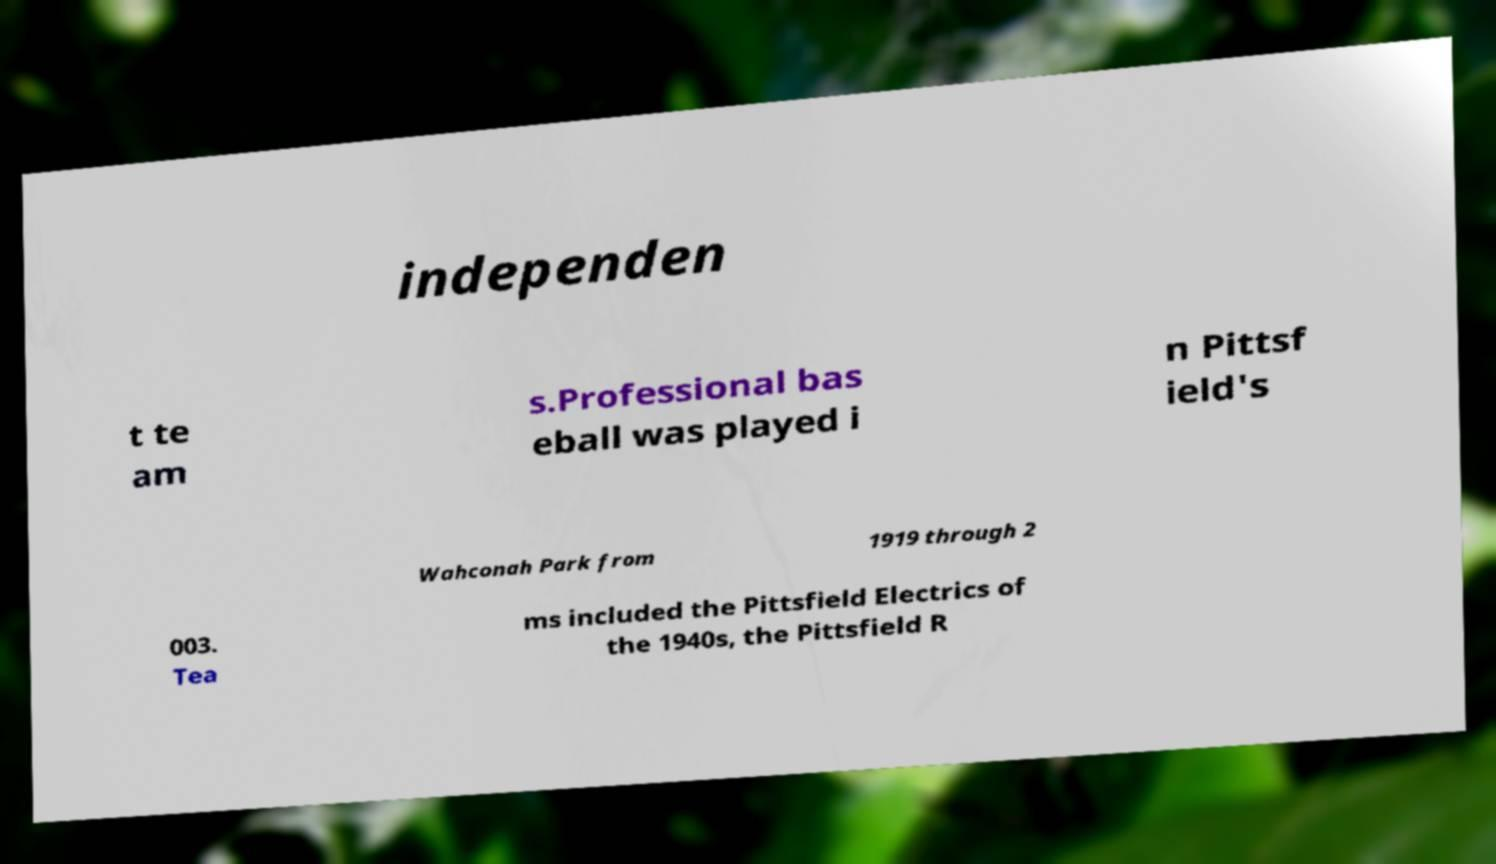Could you assist in decoding the text presented in this image and type it out clearly? independen t te am s.Professional bas eball was played i n Pittsf ield's Wahconah Park from 1919 through 2 003. Tea ms included the Pittsfield Electrics of the 1940s, the Pittsfield R 